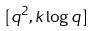<formula> <loc_0><loc_0><loc_500><loc_500>[ q ^ { 2 } , k \log q ]</formula> 